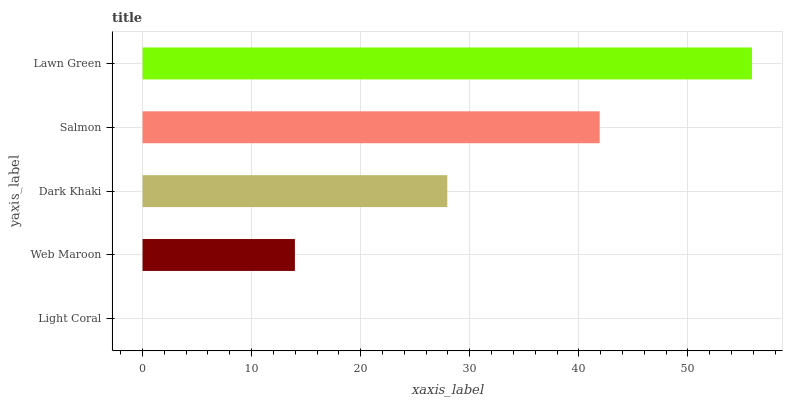Is Light Coral the minimum?
Answer yes or no. Yes. Is Lawn Green the maximum?
Answer yes or no. Yes. Is Web Maroon the minimum?
Answer yes or no. No. Is Web Maroon the maximum?
Answer yes or no. No. Is Web Maroon greater than Light Coral?
Answer yes or no. Yes. Is Light Coral less than Web Maroon?
Answer yes or no. Yes. Is Light Coral greater than Web Maroon?
Answer yes or no. No. Is Web Maroon less than Light Coral?
Answer yes or no. No. Is Dark Khaki the high median?
Answer yes or no. Yes. Is Dark Khaki the low median?
Answer yes or no. Yes. Is Lawn Green the high median?
Answer yes or no. No. Is Light Coral the low median?
Answer yes or no. No. 